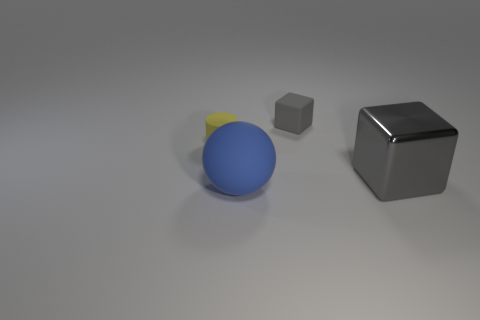Add 4 large rubber spheres. How many objects exist? 8 Subtract all spheres. How many objects are left? 3 Subtract 1 blocks. How many blocks are left? 1 Subtract 1 blue balls. How many objects are left? 3 Subtract all green balls. Subtract all gray cylinders. How many balls are left? 1 Subtract all green spheres. How many purple cylinders are left? 0 Subtract all gray metallic cylinders. Subtract all tiny gray things. How many objects are left? 3 Add 3 tiny yellow objects. How many tiny yellow objects are left? 4 Add 4 tiny yellow matte cylinders. How many tiny yellow matte cylinders exist? 5 